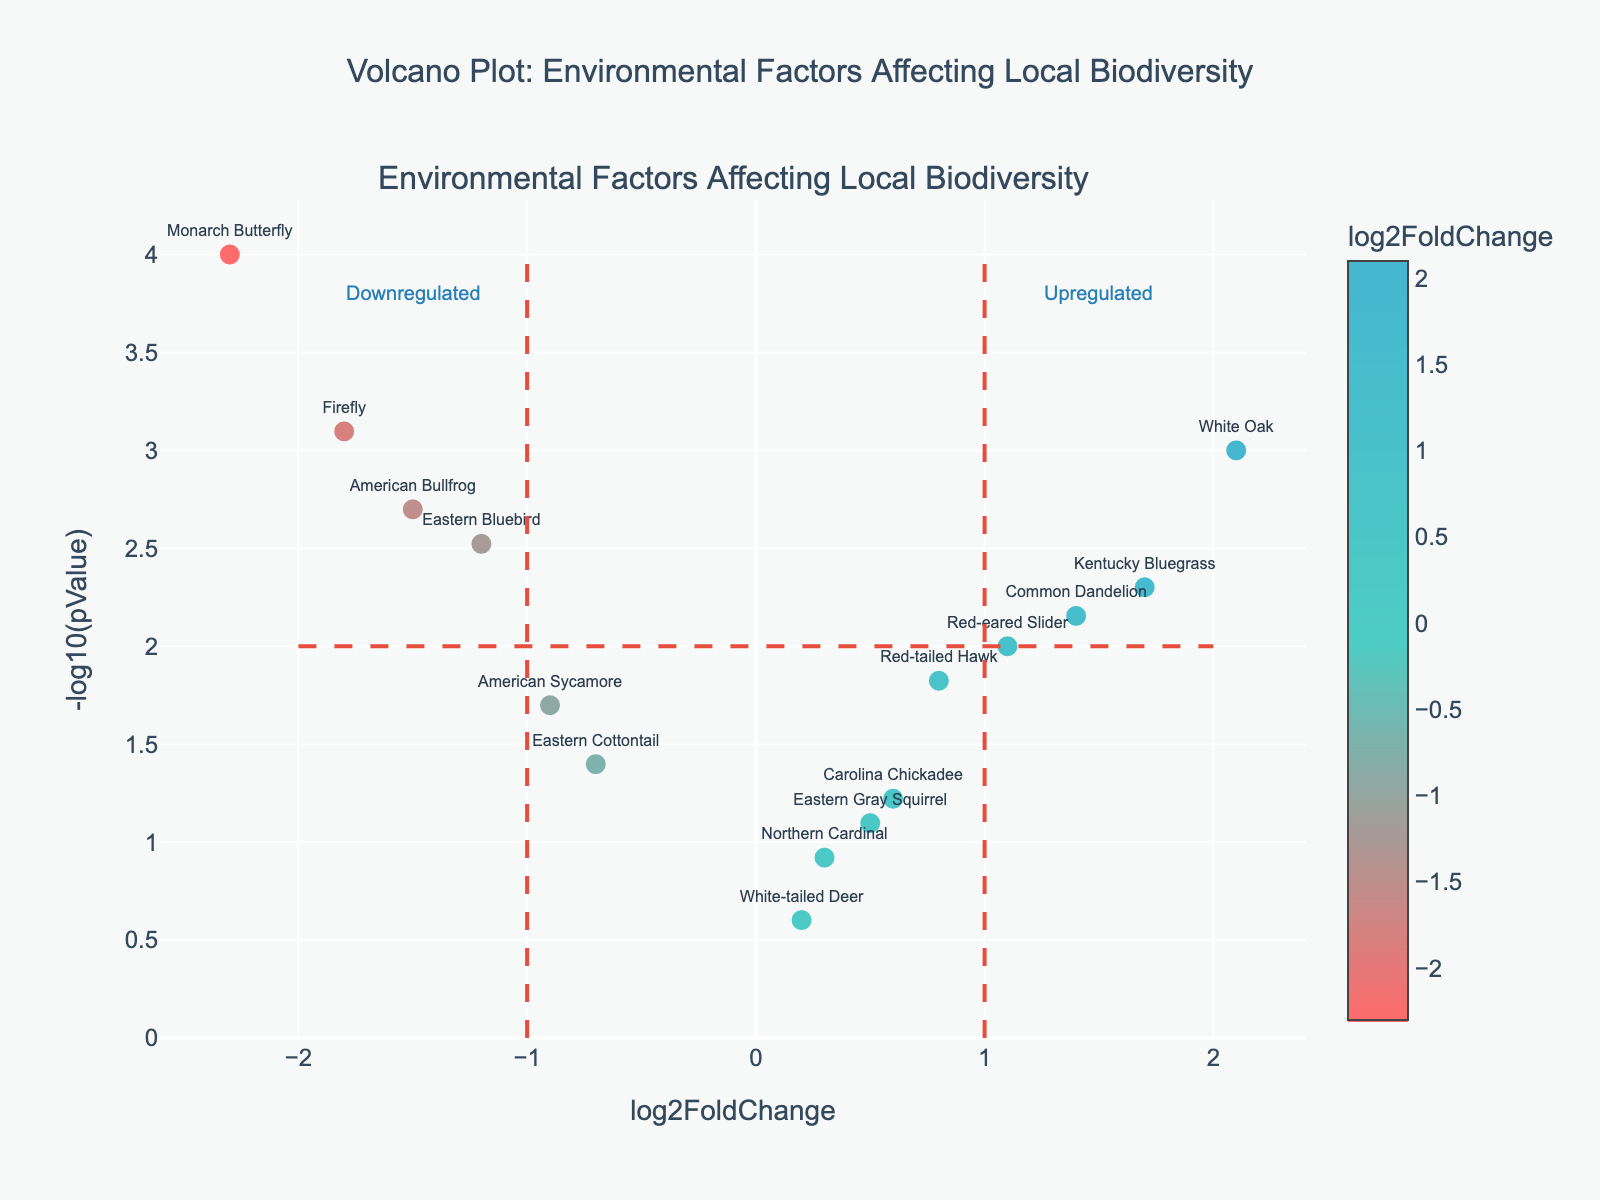What's the title of the volcano plot? The title is displayed at the top of the plot. It reads, "Volcano Plot: Environmental Factors Affecting Local Biodiversity."
Answer: Volcano Plot: Environmental Factors Affecting Local Biodiversity How many species are included in the plot? By counting the number of data points in the plot, or by referring to the data, we see that there are 15 species plotted.
Answer: 15 Which species has the highest negative log2FoldChange? The species with the most negative log2FoldChange will be the leftmost point on the plot. This is the Monarch Butterfly with a log2FoldChange of -2.3.
Answer: Monarch Butterfly What is the value of -log10(pValue) for the White Oak? Locate the data point labeled White Oak and note its corresponding y-value, which represents -log10(pValue). This value is 3 as -log10(0.001) = 3.
Answer: 3 Which species are considered upregulated? Upregulated species are those with a log2FoldChange greater than 1, marked on the right side of the vertical line at log2FoldChange = 1. The species are Red-eared Slider and White Oak.
Answer: Red-eared Slider, White Oak What is the approximate log2FoldChange for the Firefly? Locate the data point labeled Firefly and note its x-value, which represents the log2FoldChange. The approximate value is -1.8.
Answer: -1.8 Are there more species with a negative or positive log2FoldChange? Count the number of species with negative and positive log2FoldChange values. There are 8 species with negative and 7 with positive log2FoldChange.
Answer: Negative Which species is closest to being unaffected, with a log2FoldChange near 0? The species closest to the vertical line at log2FoldChange = 0 are White-tailed Deer and Northern Cardinal. Among them, Northern Cardinal, with a log2FoldChange of 0.3, is the closest.
Answer: Northern Cardinal What is the relationship between pValue and -log10(pValue)? From the plot, we can infer that lower pValues correspond to higher -log10(pValues). This inverse relationship holds because -log10(pValue) transforms lower pValues into higher positive y-values.
Answer: Inverse relationship Which species is more significantly downregulated, American Bullfrog or Eastern Cottontail? Compare the y-values (-log10(pValue)) of the two species. American Bullfrog, with a -log10(pValue) of 2.7 (pValue of 0.002), is more significantly downregulated compared to Eastern Cottontail, with a -log10(pValue) of 1.4 (pValue of 0.04).
Answer: American Bullfrog 